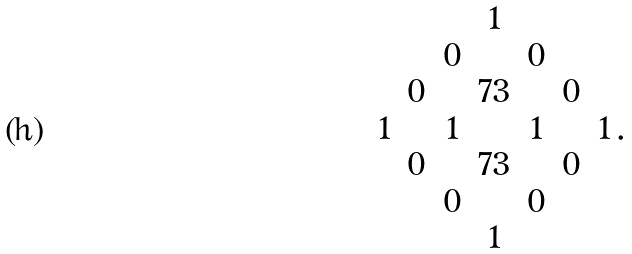Convert formula to latex. <formula><loc_0><loc_0><loc_500><loc_500>\begin{matrix} & & & 1 & & & \\ & & 0 & & 0 & & \\ & 0 & & 7 3 & & 0 & \\ 1 & & 1 & & 1 & & 1 \\ & 0 & & 7 3 & & 0 & \\ & & 0 & & 0 & & \\ & & & 1 & & & \\ \end{matrix} \, .</formula> 